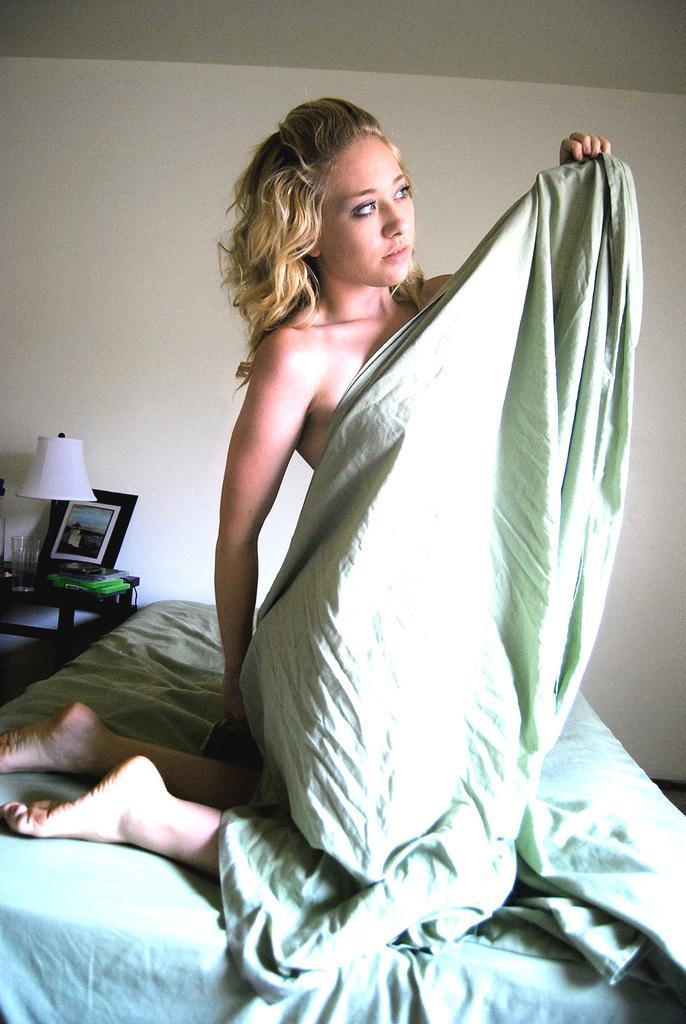Please provide a concise description of this image. In this image I can see a woman and a cloth. In the background I can see a bed, a photo frame and a lamp. 